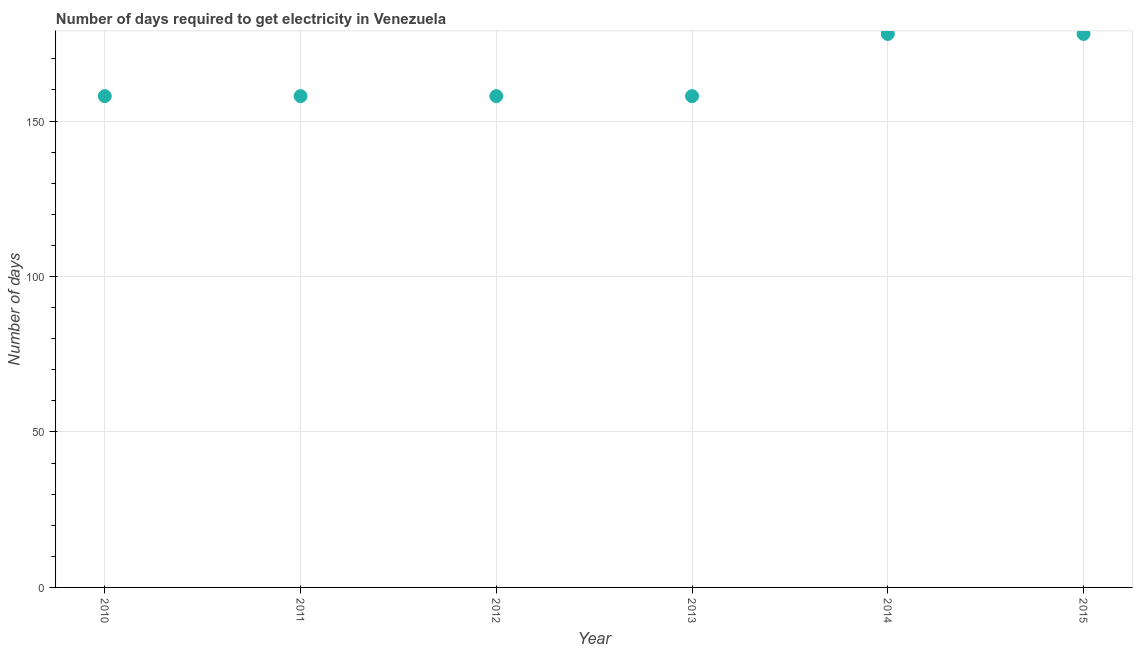What is the time to get electricity in 2010?
Ensure brevity in your answer.  158. Across all years, what is the maximum time to get electricity?
Your answer should be very brief. 178. Across all years, what is the minimum time to get electricity?
Your answer should be very brief. 158. In which year was the time to get electricity maximum?
Provide a succinct answer. 2014. In which year was the time to get electricity minimum?
Your response must be concise. 2010. What is the sum of the time to get electricity?
Provide a succinct answer. 988. What is the difference between the time to get electricity in 2013 and 2015?
Ensure brevity in your answer.  -20. What is the average time to get electricity per year?
Your answer should be very brief. 164.67. What is the median time to get electricity?
Give a very brief answer. 158. What is the ratio of the time to get electricity in 2011 to that in 2013?
Provide a succinct answer. 1. Is the time to get electricity in 2011 less than that in 2015?
Provide a succinct answer. Yes. Is the difference between the time to get electricity in 2010 and 2011 greater than the difference between any two years?
Your answer should be compact. No. What is the difference between the highest and the second highest time to get electricity?
Offer a terse response. 0. What is the difference between the highest and the lowest time to get electricity?
Make the answer very short. 20. Does the time to get electricity monotonically increase over the years?
Give a very brief answer. No. How many dotlines are there?
Your answer should be compact. 1. What is the difference between two consecutive major ticks on the Y-axis?
Offer a very short reply. 50. Does the graph contain grids?
Ensure brevity in your answer.  Yes. What is the title of the graph?
Provide a short and direct response. Number of days required to get electricity in Venezuela. What is the label or title of the Y-axis?
Make the answer very short. Number of days. What is the Number of days in 2010?
Give a very brief answer. 158. What is the Number of days in 2011?
Give a very brief answer. 158. What is the Number of days in 2012?
Provide a succinct answer. 158. What is the Number of days in 2013?
Keep it short and to the point. 158. What is the Number of days in 2014?
Provide a short and direct response. 178. What is the Number of days in 2015?
Offer a very short reply. 178. What is the difference between the Number of days in 2010 and 2012?
Your answer should be compact. 0. What is the difference between the Number of days in 2010 and 2014?
Make the answer very short. -20. What is the difference between the Number of days in 2010 and 2015?
Give a very brief answer. -20. What is the difference between the Number of days in 2011 and 2013?
Provide a succinct answer. 0. What is the difference between the Number of days in 2013 and 2014?
Provide a short and direct response. -20. What is the ratio of the Number of days in 2010 to that in 2011?
Keep it short and to the point. 1. What is the ratio of the Number of days in 2010 to that in 2014?
Ensure brevity in your answer.  0.89. What is the ratio of the Number of days in 2010 to that in 2015?
Ensure brevity in your answer.  0.89. What is the ratio of the Number of days in 2011 to that in 2012?
Offer a terse response. 1. What is the ratio of the Number of days in 2011 to that in 2013?
Offer a very short reply. 1. What is the ratio of the Number of days in 2011 to that in 2014?
Ensure brevity in your answer.  0.89. What is the ratio of the Number of days in 2011 to that in 2015?
Your answer should be compact. 0.89. What is the ratio of the Number of days in 2012 to that in 2014?
Give a very brief answer. 0.89. What is the ratio of the Number of days in 2012 to that in 2015?
Offer a terse response. 0.89. What is the ratio of the Number of days in 2013 to that in 2014?
Make the answer very short. 0.89. What is the ratio of the Number of days in 2013 to that in 2015?
Your answer should be compact. 0.89. 